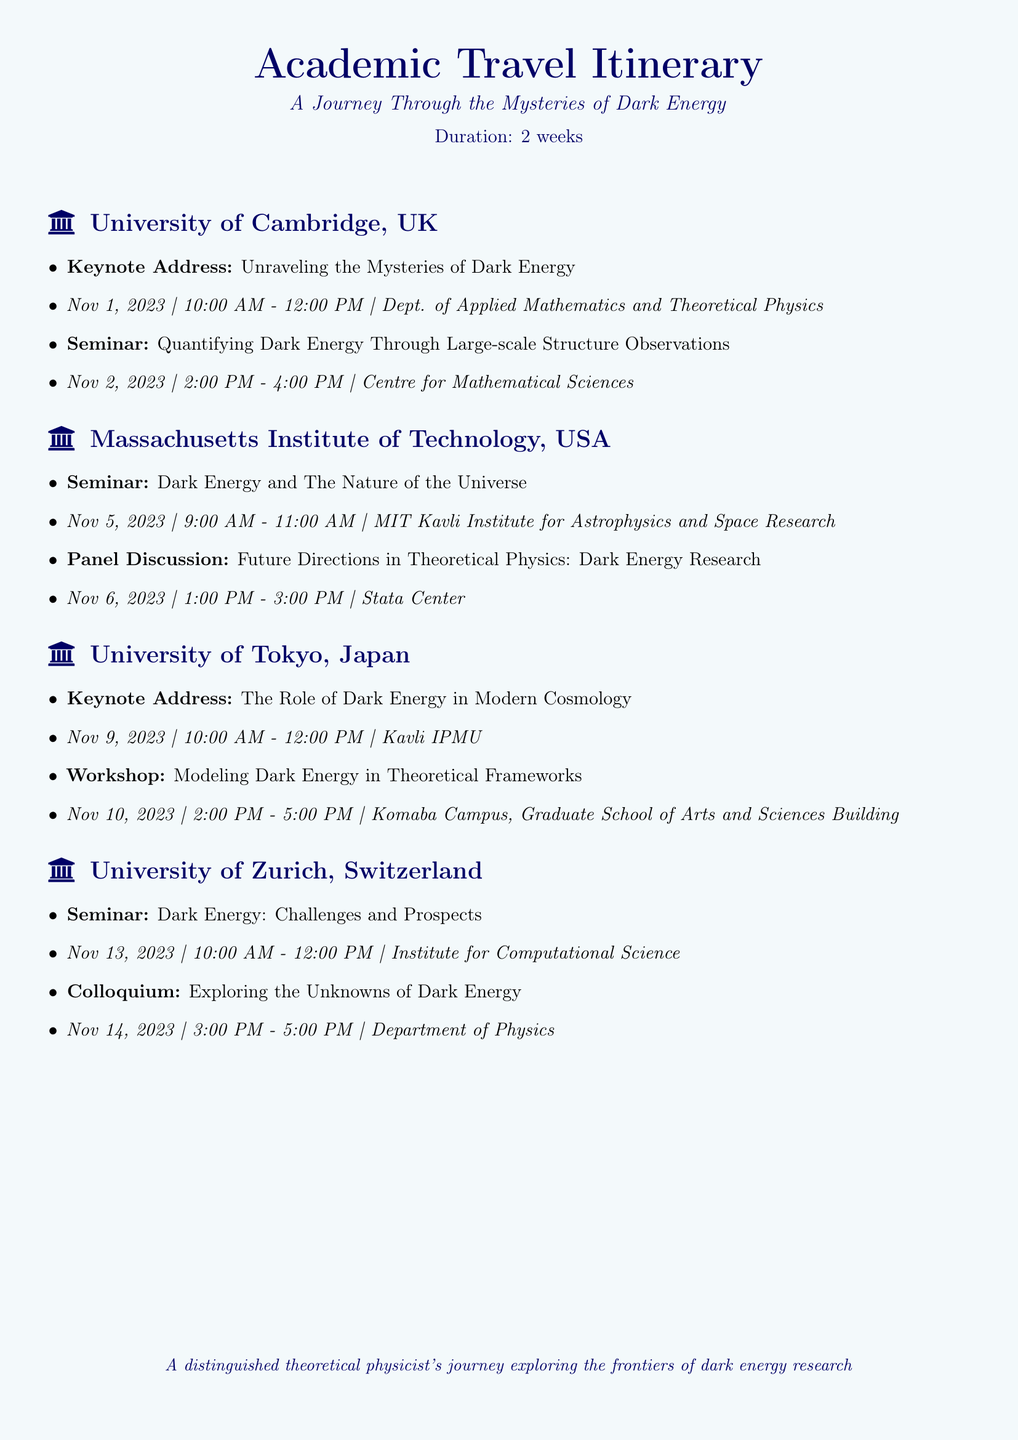what is the duration of the itinerary? The duration of the itinerary is explicitly stated at the beginning of the document as two weeks.
Answer: two weeks how many seminars are listed at the University of Cambridge? There are two events listed, including one keynote address and one seminar, which counts as one seminar.
Answer: one which university hosts a panel discussion on dark energy research? The document specifies that the Massachusetts Institute of Technology hosts a panel discussion.
Answer: Massachusetts Institute of Technology what is the title of the seminar at the University of Zurich? The title of the seminar is clearly mentioned in the event listing for the University of Zurich.
Answer: Dark Energy: Challenges and Prospects how many keynote addresses are scheduled during the itinerary? By reviewing the schedule of events, we can count the number of keynote addresses.
Answer: three which institution will have a workshop related to dark energy? The document states the University of Tokyo will have a workshop on modeling dark energy.
Answer: University of Tokyo what is the main focus of the seminar at MIT? The topic of the seminar is directly included in the description of the event at MIT.
Answer: Dark Energy and The Nature of the Universe which day features a colloquium at the University of Zurich? The document provides the specific date when the colloquium will take place at the University of Zurich.
Answer: Nov 14, 2023 